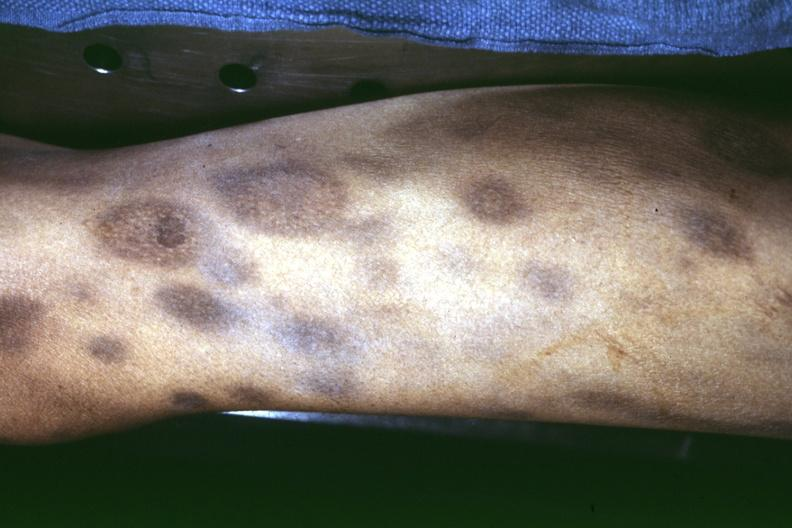how does thigh at autopsy ecchymose?
Answer the question using a single word or phrase. With necrotizing centers 